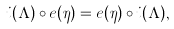<formula> <loc_0><loc_0><loc_500><loc_500>i ( \Lambda ) \circ e ( \eta ) = e ( \eta ) \circ i ( \Lambda ) ,</formula> 